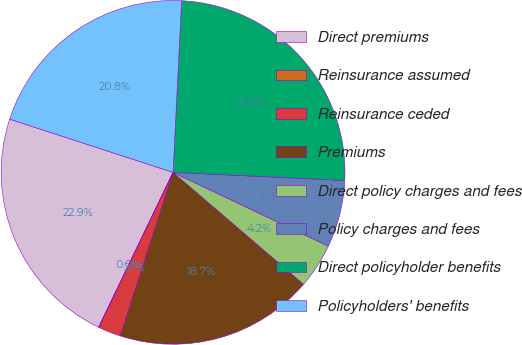Convert chart. <chart><loc_0><loc_0><loc_500><loc_500><pie_chart><fcel>Direct premiums<fcel>Reinsurance assumed<fcel>Reinsurance ceded<fcel>Premiums<fcel>Direct policy charges and fees<fcel>Policy charges and fees<fcel>Direct policyholder benefits<fcel>Policyholders' benefits<nl><fcel>22.87%<fcel>0.04%<fcel>2.13%<fcel>18.69%<fcel>4.22%<fcel>6.31%<fcel>24.96%<fcel>20.78%<nl></chart> 